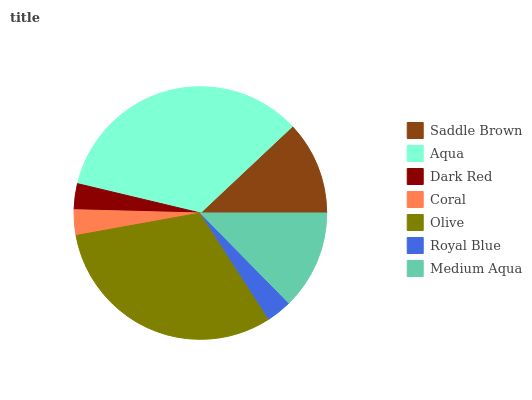Is Royal Blue the minimum?
Answer yes or no. Yes. Is Aqua the maximum?
Answer yes or no. Yes. Is Dark Red the minimum?
Answer yes or no. No. Is Dark Red the maximum?
Answer yes or no. No. Is Aqua greater than Dark Red?
Answer yes or no. Yes. Is Dark Red less than Aqua?
Answer yes or no. Yes. Is Dark Red greater than Aqua?
Answer yes or no. No. Is Aqua less than Dark Red?
Answer yes or no. No. Is Saddle Brown the high median?
Answer yes or no. Yes. Is Saddle Brown the low median?
Answer yes or no. Yes. Is Dark Red the high median?
Answer yes or no. No. Is Aqua the low median?
Answer yes or no. No. 